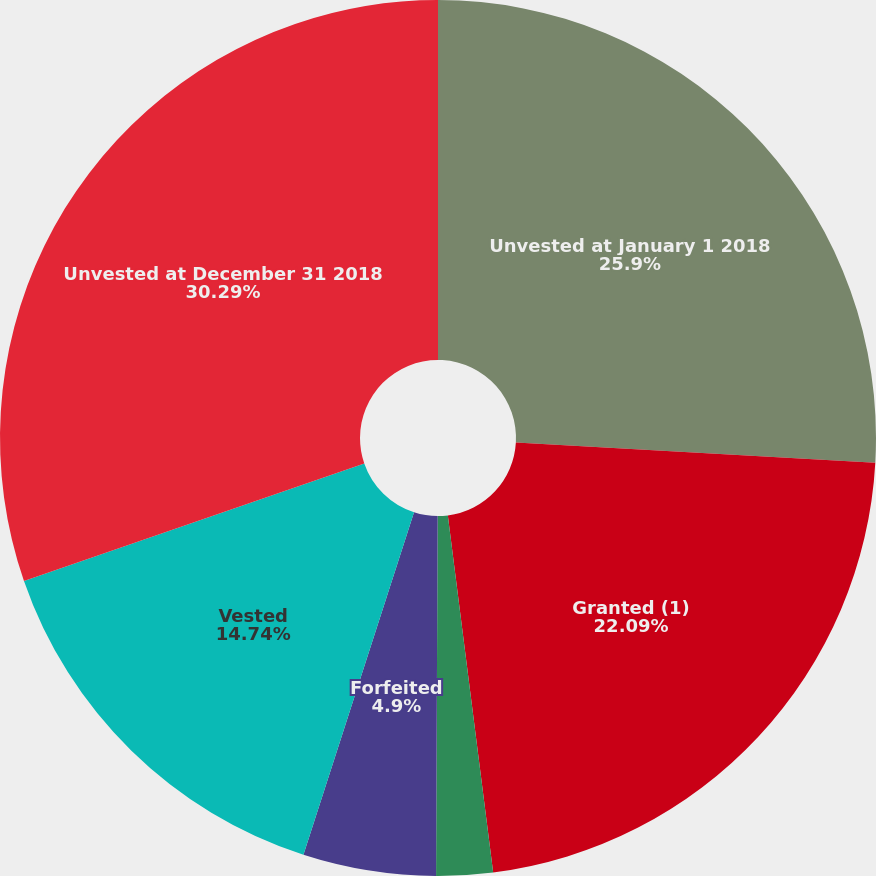Convert chart to OTSL. <chart><loc_0><loc_0><loc_500><loc_500><pie_chart><fcel>Unvested at January 1 2018<fcel>Granted (1)<fcel>Surrendered upon spin-off (2)<fcel>Forfeited<fcel>Vested<fcel>Unvested at December 31 2018<nl><fcel>25.9%<fcel>22.09%<fcel>2.08%<fcel>4.9%<fcel>14.74%<fcel>30.29%<nl></chart> 